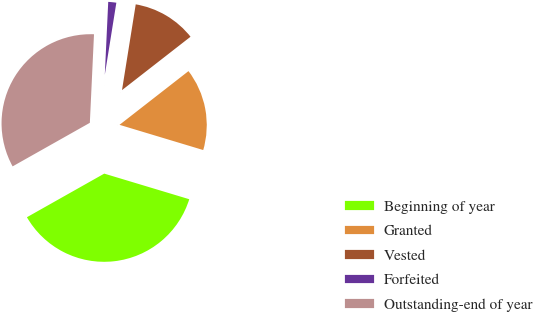Convert chart to OTSL. <chart><loc_0><loc_0><loc_500><loc_500><pie_chart><fcel>Beginning of year<fcel>Granted<fcel>Vested<fcel>Forfeited<fcel>Outstanding-end of year<nl><fcel>37.17%<fcel>15.19%<fcel>11.94%<fcel>1.78%<fcel>33.92%<nl></chart> 